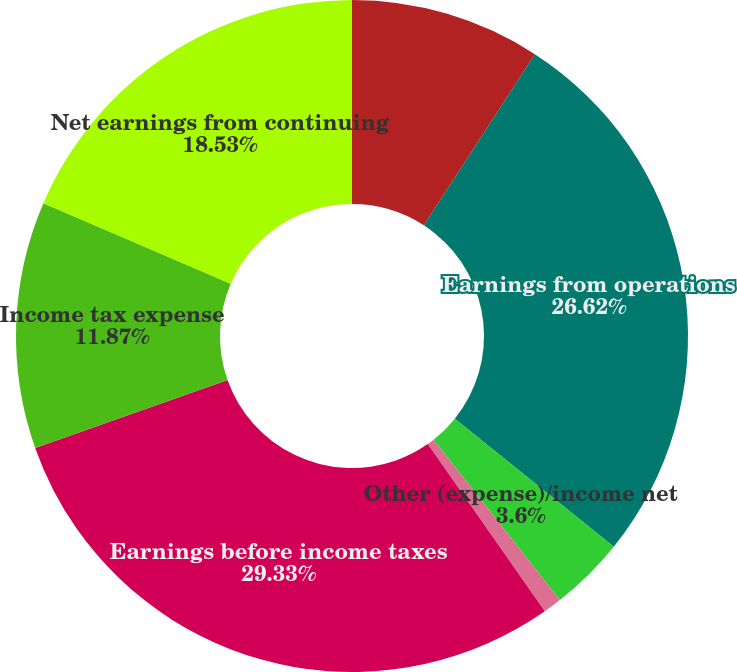<chart> <loc_0><loc_0><loc_500><loc_500><pie_chart><fcel>(Dollars in millions) Years<fcel>Earnings from operations<fcel>Other (expense)/income net<fcel>Interest and debt expense<fcel>Earnings before income taxes<fcel>Income tax expense<fcel>Net earnings from continuing<nl><fcel>9.16%<fcel>26.62%<fcel>3.6%<fcel>0.89%<fcel>29.32%<fcel>11.87%<fcel>18.53%<nl></chart> 